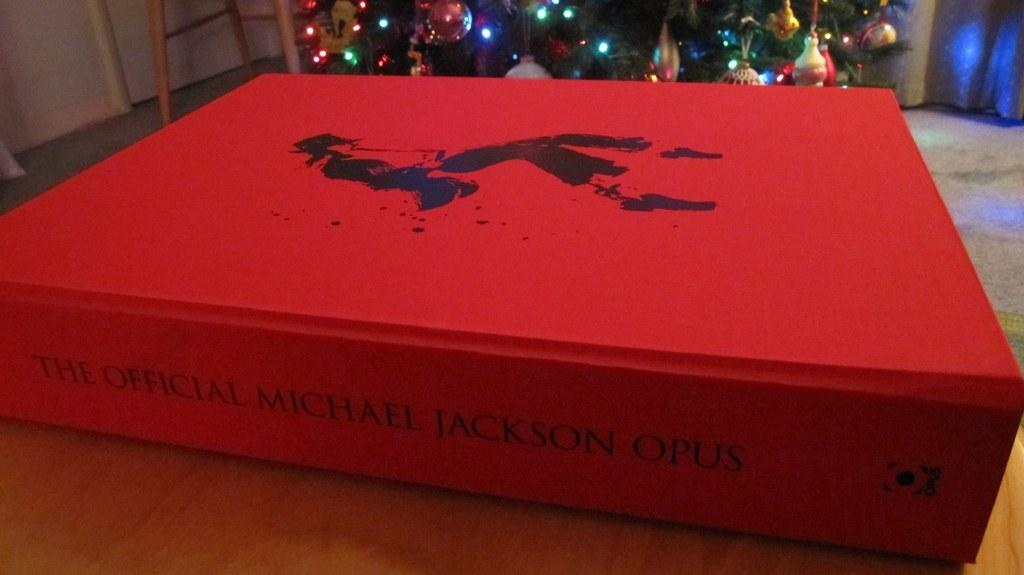Provide a one-sentence caption for the provided image. A RED HARDVERED BOOK CALLED THE OFFICAL MICHAEL JACKSON OPUS. 